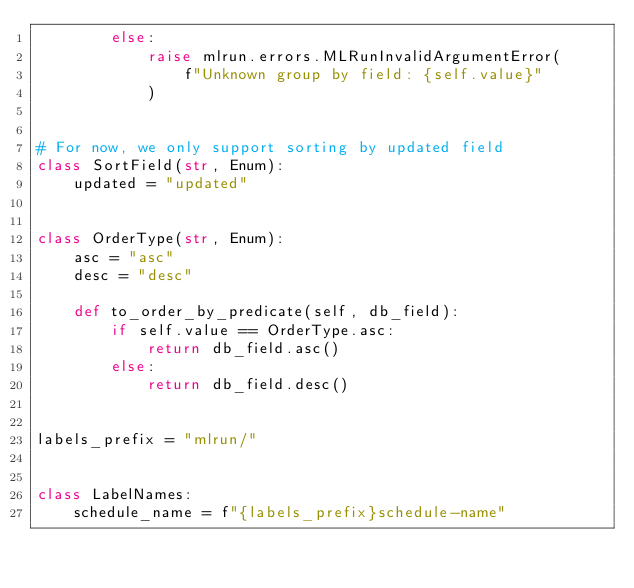<code> <loc_0><loc_0><loc_500><loc_500><_Python_>        else:
            raise mlrun.errors.MLRunInvalidArgumentError(
                f"Unknown group by field: {self.value}"
            )


# For now, we only support sorting by updated field
class SortField(str, Enum):
    updated = "updated"


class OrderType(str, Enum):
    asc = "asc"
    desc = "desc"

    def to_order_by_predicate(self, db_field):
        if self.value == OrderType.asc:
            return db_field.asc()
        else:
            return db_field.desc()


labels_prefix = "mlrun/"


class LabelNames:
    schedule_name = f"{labels_prefix}schedule-name"
</code> 